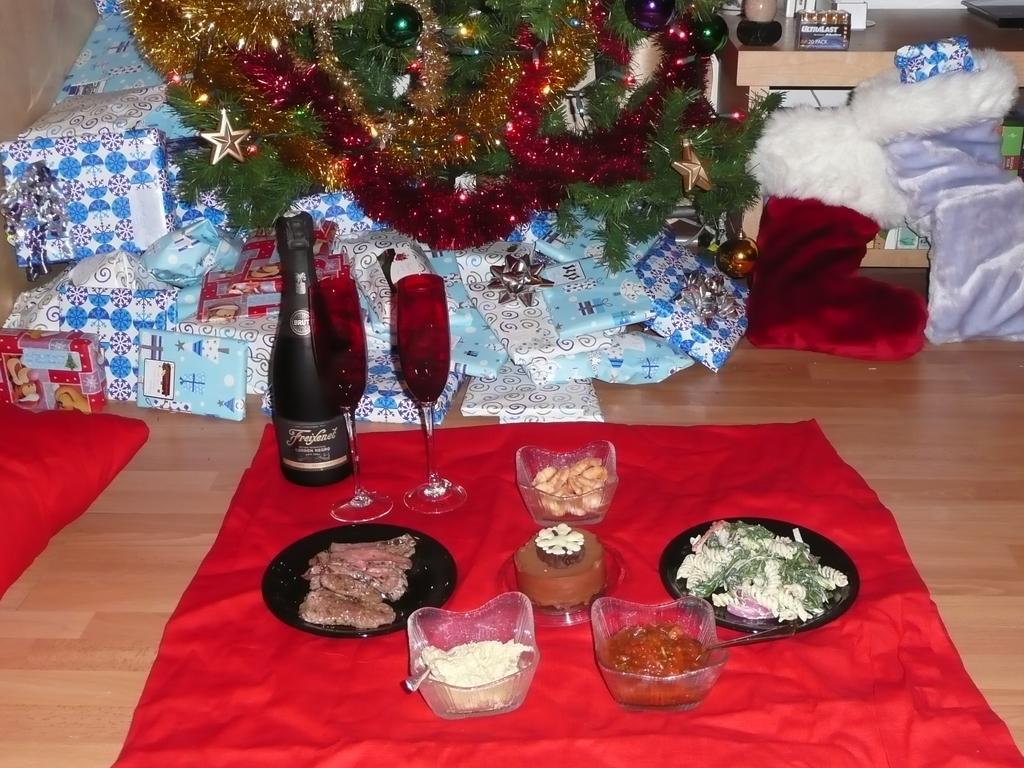Describe this image in one or two sentences. This picture is clicked inside. In the foreground there is a table on the top of which gifts and Christmas tree, glasses, bottle and some food items and some other items are placed. 